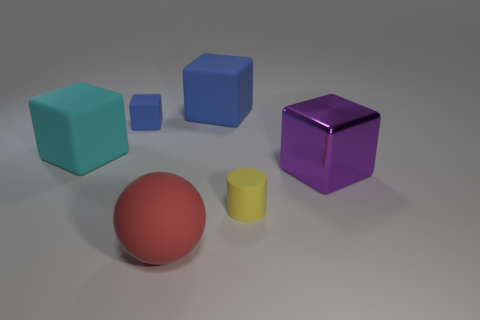Is there a small green ball?
Give a very brief answer. No. What number of large matte things are the same color as the tiny cube?
Offer a terse response. 1. What number of objects are purple blocks in front of the tiny blue matte block or large blocks behind the big purple cube?
Your answer should be compact. 3. How many small rubber objects are right of the small matte thing behind the metallic cube?
Your answer should be very brief. 1. What is the color of the small cylinder that is the same material as the red object?
Offer a very short reply. Yellow. Is there a yellow thing that has the same size as the purple shiny thing?
Keep it short and to the point. No. The blue rubber thing that is the same size as the metal thing is what shape?
Your answer should be very brief. Cube. Are there any small gray metallic things of the same shape as the large shiny thing?
Ensure brevity in your answer.  No. Is the material of the big sphere the same as the block that is to the right of the yellow matte object?
Provide a succinct answer. No. Are there any other rubber cubes that have the same color as the tiny cube?
Keep it short and to the point. Yes. 